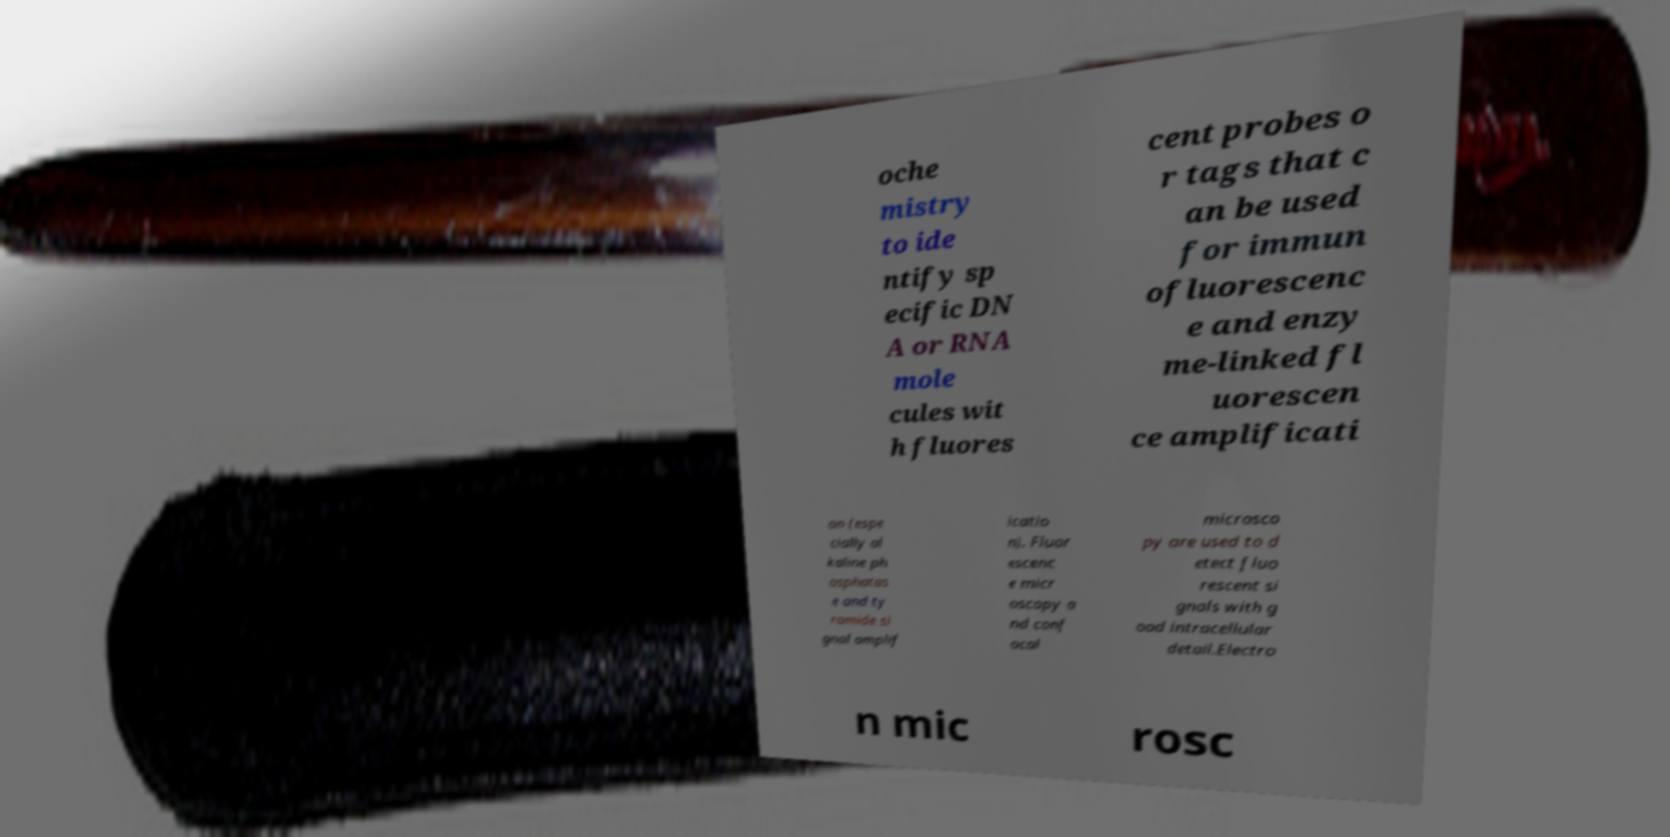Please identify and transcribe the text found in this image. oche mistry to ide ntify sp ecific DN A or RNA mole cules wit h fluores cent probes o r tags that c an be used for immun ofluorescenc e and enzy me-linked fl uorescen ce amplificati on (espe cially al kaline ph osphatas e and ty ramide si gnal amplif icatio n). Fluor escenc e micr oscopy a nd conf ocal microsco py are used to d etect fluo rescent si gnals with g ood intracellular detail.Electro n mic rosc 